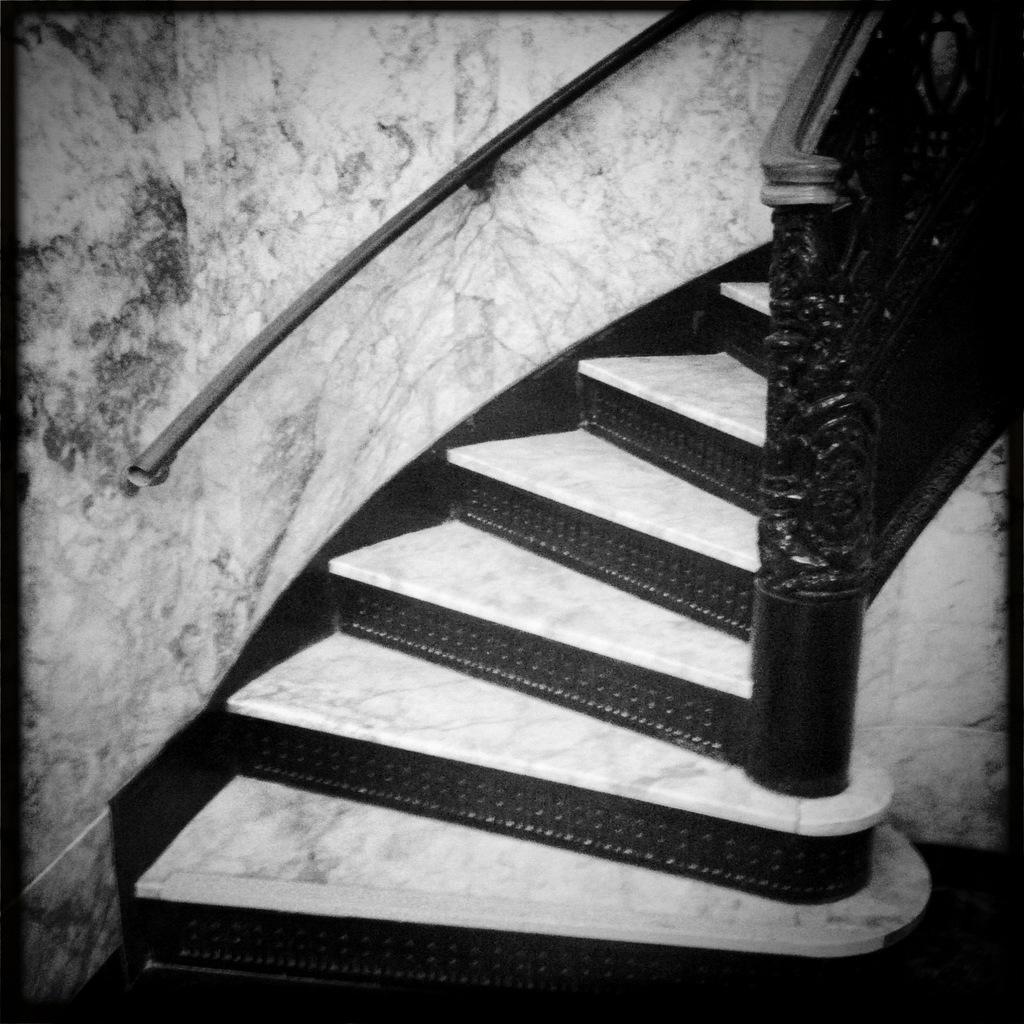What type of railing can be seen in the image? There is a black color railing in the image. What objects are on the steps in the image? There are marbles on the steps in the image. What color scheme is used in the image? The image is black and white. What type of pie is being served in the image? There is no pie present in the image. What month is depicted in the image? The image does not depict a specific month; it is a black and white image with a railing and marbles on the steps. 